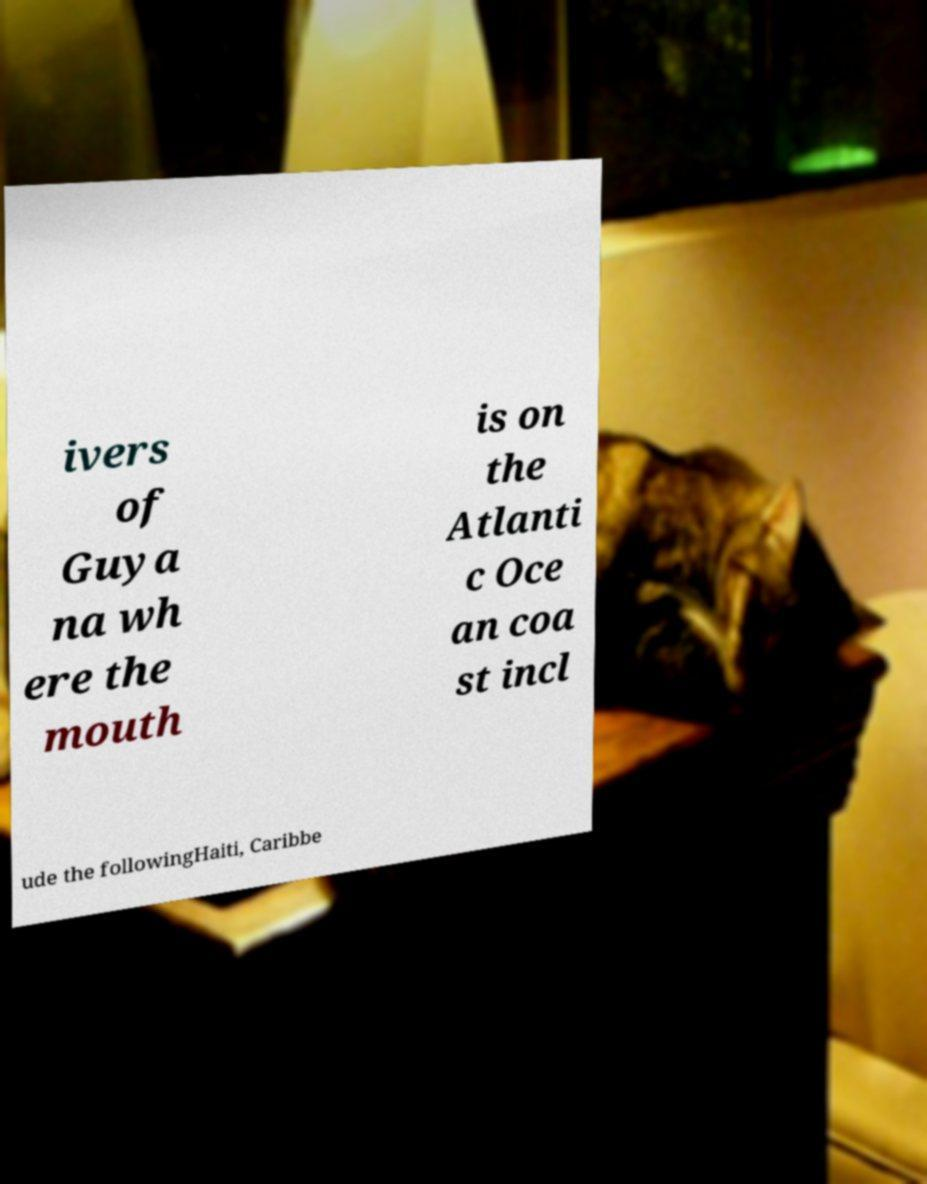Please read and relay the text visible in this image. What does it say? ivers of Guya na wh ere the mouth is on the Atlanti c Oce an coa st incl ude the followingHaiti, Caribbe 